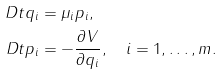<formula> <loc_0><loc_0><loc_500><loc_500>\ D t q _ { i } & = \mu _ { i } p _ { i } , \\ \ D t p _ { i } & = - \frac { \partial V } { \partial q _ { i } } , \quad i = 1 , \dots , m .</formula> 